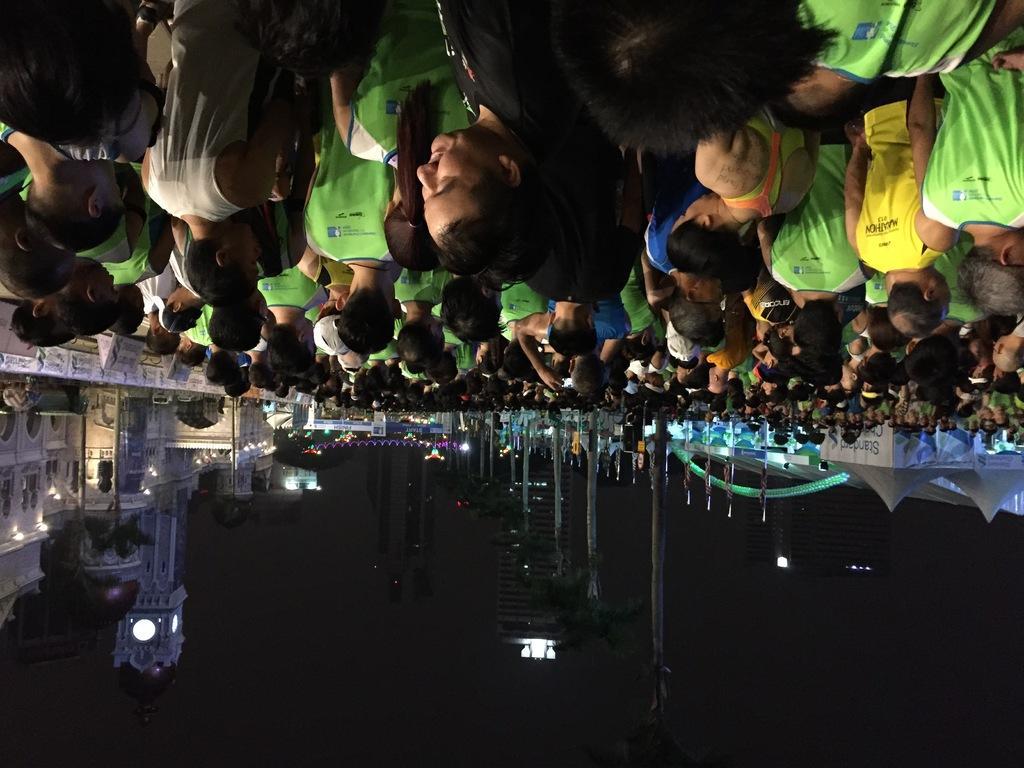Describe this image in one or two sentences. This image is in reverse direction. At the top of the image I can see a crowd of people. At the bottom there are buildings, lights and poles. This is an image clicked in the dark. 